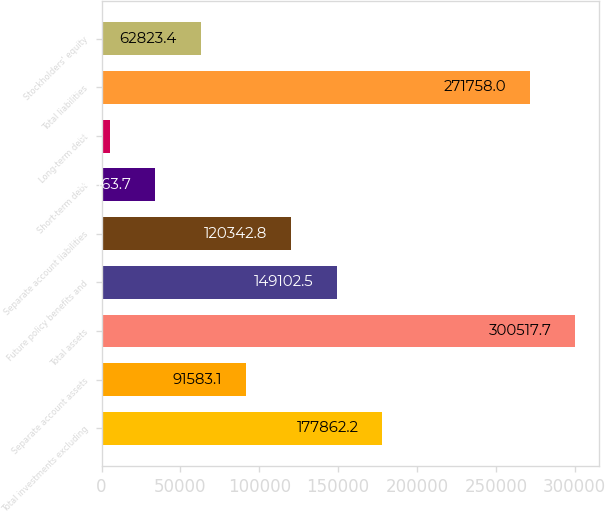Convert chart to OTSL. <chart><loc_0><loc_0><loc_500><loc_500><bar_chart><fcel>Total investments excluding<fcel>Separate account assets<fcel>Total assets<fcel>Future policy benefits and<fcel>Separate account liabilities<fcel>Short-term debt<fcel>Long-term debt<fcel>Total liabilities<fcel>Stockholders' equity<nl><fcel>177862<fcel>91583.1<fcel>300518<fcel>149102<fcel>120343<fcel>34063.7<fcel>5304<fcel>271758<fcel>62823.4<nl></chart> 